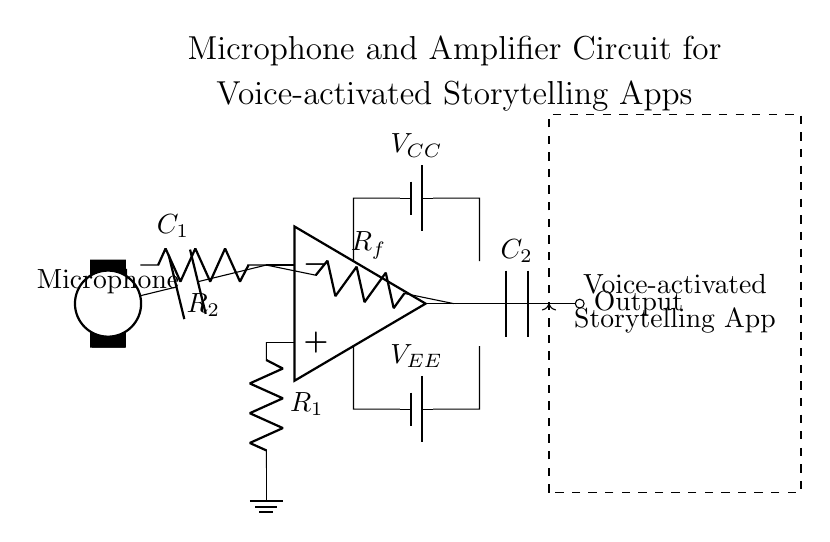What type of components are used in this circuit? The circuit contains operational amplifiers, resistors, capacitors, and microphones. These components are essential for amplifying audio signals.
Answer: operational amplifiers, resistors, capacitors, microphone What is the role of the microphone? The microphone converts sound into an electrical signal, acting as the input for the amplifier in the circuit.
Answer: input signal What does R_f represent in the circuit? R_f is the feedback resistor connected across the output and the inverting input of the op-amp, controlling the gain of the amplifier.
Answer: feedback resistor How many capacitors are in the circuit? There are two capacitors, C_1 and C_2, which are used to block DC components and may allow AC signals to pass.
Answer: two What is the significance of V_CC and V_EE? V_CC provides positive voltage and V_EE provides negative voltage, necessary for powering the operational amplifier, allowing it to operate effectively.
Answer: power supply voltages How does the signal flow from the microphone to the output? The signal flows from the microphone to the input of the amplifier (via C_1), is amplified by the op-amp and then sent to the output through C_2.
Answer: microphone to op-amp to output What type of app is associated with this circuit? The circuit is associated with a voice-activated storytelling app, which utilizes voice input to initiate storytelling functions.
Answer: voice-activated storytelling app 